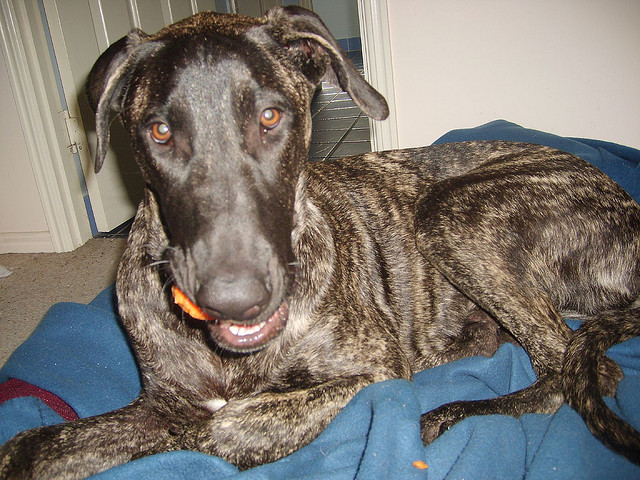<image>What breed of dog is this? I don't know the breed of the dog. It can range from lab, greyhound, mutt, doberman to great dane. What breed of dog is this? I am not sure what breed of dog it is. It can be seen as labrador, greyhound, mutt, doberman, or great dane. 